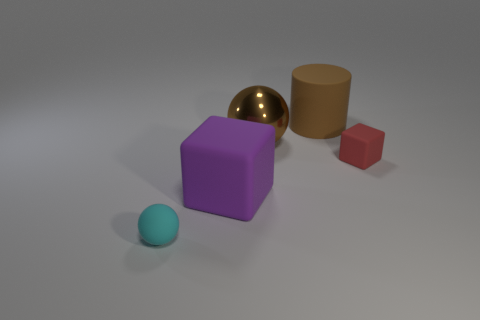How many other things are the same shape as the small cyan rubber thing?
Give a very brief answer. 1. Is the number of red blocks that are on the right side of the tiny matte cube less than the number of rubber objects that are to the left of the matte cylinder?
Your response must be concise. Yes. How many purple blocks are behind the small object behind the cyan matte thing?
Ensure brevity in your answer.  0. Are any brown metal balls visible?
Provide a short and direct response. Yes. Are there any large blocks made of the same material as the small cyan ball?
Provide a succinct answer. Yes. Are there more red objects that are on the right side of the big purple matte cube than tiny rubber balls that are behind the matte cylinder?
Your answer should be compact. Yes. Is the size of the cylinder the same as the cyan ball?
Offer a very short reply. No. There is a large rubber object behind the purple rubber thing behind the tiny cyan object; what is its color?
Provide a short and direct response. Brown. What is the color of the matte cylinder?
Ensure brevity in your answer.  Brown. Are there any big shiny objects of the same color as the large rubber block?
Offer a very short reply. No. 